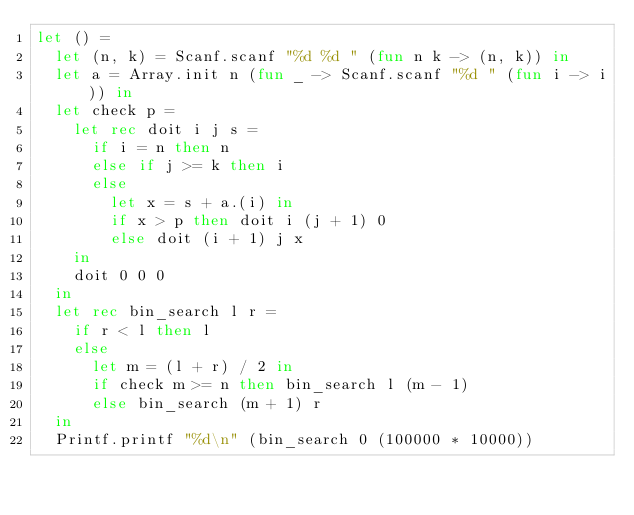Convert code to text. <code><loc_0><loc_0><loc_500><loc_500><_OCaml_>let () =
  let (n, k) = Scanf.scanf "%d %d " (fun n k -> (n, k)) in
  let a = Array.init n (fun _ -> Scanf.scanf "%d " (fun i -> i)) in
  let check p =
    let rec doit i j s =
      if i = n then n
      else if j >= k then i
      else
        let x = s + a.(i) in
        if x > p then doit i (j + 1) 0
        else doit (i + 1) j x
    in
    doit 0 0 0
  in
  let rec bin_search l r =
    if r < l then l
    else
      let m = (l + r) / 2 in
      if check m >= n then bin_search l (m - 1)
      else bin_search (m + 1) r
  in
  Printf.printf "%d\n" (bin_search 0 (100000 * 10000))</code> 